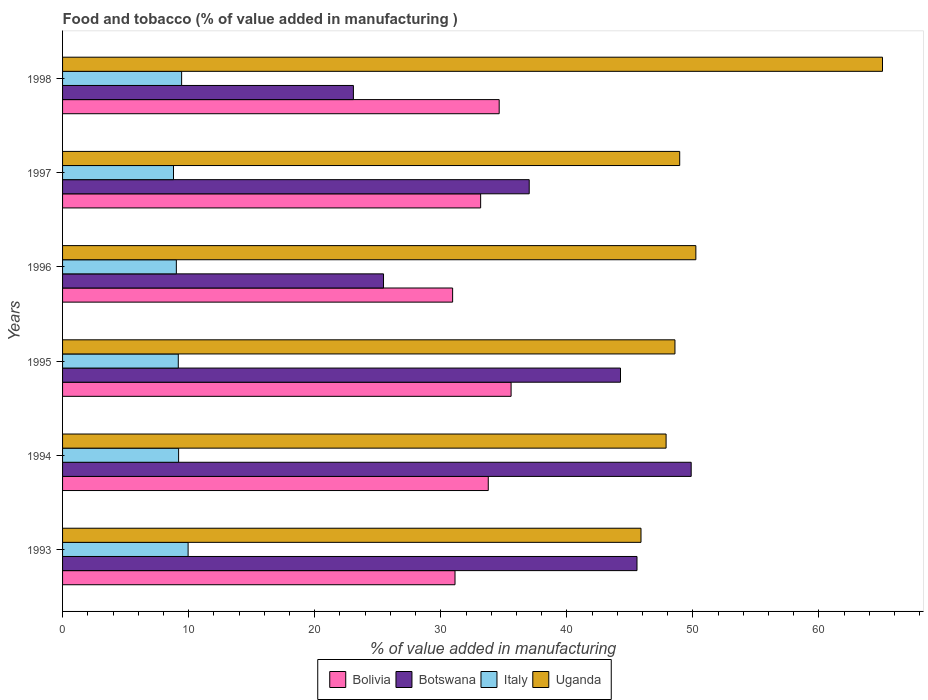How many groups of bars are there?
Your response must be concise. 6. How many bars are there on the 4th tick from the bottom?
Make the answer very short. 4. In how many cases, is the number of bars for a given year not equal to the number of legend labels?
Make the answer very short. 0. What is the value added in manufacturing food and tobacco in Botswana in 1993?
Give a very brief answer. 45.56. Across all years, what is the maximum value added in manufacturing food and tobacco in Italy?
Offer a terse response. 9.96. Across all years, what is the minimum value added in manufacturing food and tobacco in Botswana?
Provide a succinct answer. 23.07. What is the total value added in manufacturing food and tobacco in Bolivia in the graph?
Your response must be concise. 199.21. What is the difference between the value added in manufacturing food and tobacco in Italy in 1996 and that in 1998?
Your answer should be very brief. -0.42. What is the difference between the value added in manufacturing food and tobacco in Bolivia in 1994 and the value added in manufacturing food and tobacco in Botswana in 1998?
Make the answer very short. 10.7. What is the average value added in manufacturing food and tobacco in Bolivia per year?
Your answer should be compact. 33.2. In the year 1993, what is the difference between the value added in manufacturing food and tobacco in Italy and value added in manufacturing food and tobacco in Uganda?
Keep it short and to the point. -35.92. What is the ratio of the value added in manufacturing food and tobacco in Uganda in 1993 to that in 1996?
Your response must be concise. 0.91. What is the difference between the highest and the second highest value added in manufacturing food and tobacco in Botswana?
Keep it short and to the point. 4.3. What is the difference between the highest and the lowest value added in manufacturing food and tobacco in Italy?
Your answer should be compact. 1.16. Is the sum of the value added in manufacturing food and tobacco in Bolivia in 1996 and 1997 greater than the maximum value added in manufacturing food and tobacco in Botswana across all years?
Provide a succinct answer. Yes. What does the 1st bar from the top in 1998 represents?
Provide a succinct answer. Uganda. What does the 2nd bar from the bottom in 1993 represents?
Make the answer very short. Botswana. Are all the bars in the graph horizontal?
Give a very brief answer. Yes. How are the legend labels stacked?
Your answer should be compact. Horizontal. What is the title of the graph?
Provide a short and direct response. Food and tobacco (% of value added in manufacturing ). What is the label or title of the X-axis?
Make the answer very short. % of value added in manufacturing. What is the % of value added in manufacturing in Bolivia in 1993?
Provide a short and direct response. 31.13. What is the % of value added in manufacturing in Botswana in 1993?
Provide a succinct answer. 45.56. What is the % of value added in manufacturing of Italy in 1993?
Offer a terse response. 9.96. What is the % of value added in manufacturing of Uganda in 1993?
Make the answer very short. 45.88. What is the % of value added in manufacturing of Bolivia in 1994?
Keep it short and to the point. 33.77. What is the % of value added in manufacturing in Botswana in 1994?
Provide a succinct answer. 49.86. What is the % of value added in manufacturing in Italy in 1994?
Make the answer very short. 9.21. What is the % of value added in manufacturing of Uganda in 1994?
Ensure brevity in your answer.  47.87. What is the % of value added in manufacturing of Bolivia in 1995?
Your answer should be very brief. 35.58. What is the % of value added in manufacturing of Botswana in 1995?
Provide a succinct answer. 44.26. What is the % of value added in manufacturing of Italy in 1995?
Give a very brief answer. 9.18. What is the % of value added in manufacturing in Uganda in 1995?
Make the answer very short. 48.57. What is the % of value added in manufacturing in Bolivia in 1996?
Your answer should be very brief. 30.94. What is the % of value added in manufacturing of Botswana in 1996?
Give a very brief answer. 25.46. What is the % of value added in manufacturing in Italy in 1996?
Ensure brevity in your answer.  9.03. What is the % of value added in manufacturing in Uganda in 1996?
Provide a succinct answer. 50.23. What is the % of value added in manufacturing in Bolivia in 1997?
Provide a succinct answer. 33.16. What is the % of value added in manufacturing in Botswana in 1997?
Offer a terse response. 37.02. What is the % of value added in manufacturing of Italy in 1997?
Make the answer very short. 8.8. What is the % of value added in manufacturing of Uganda in 1997?
Ensure brevity in your answer.  48.95. What is the % of value added in manufacturing of Bolivia in 1998?
Make the answer very short. 34.63. What is the % of value added in manufacturing of Botswana in 1998?
Ensure brevity in your answer.  23.07. What is the % of value added in manufacturing of Italy in 1998?
Provide a succinct answer. 9.44. What is the % of value added in manufacturing in Uganda in 1998?
Ensure brevity in your answer.  65.04. Across all years, what is the maximum % of value added in manufacturing in Bolivia?
Offer a very short reply. 35.58. Across all years, what is the maximum % of value added in manufacturing in Botswana?
Your answer should be very brief. 49.86. Across all years, what is the maximum % of value added in manufacturing in Italy?
Ensure brevity in your answer.  9.96. Across all years, what is the maximum % of value added in manufacturing in Uganda?
Your response must be concise. 65.04. Across all years, what is the minimum % of value added in manufacturing in Bolivia?
Keep it short and to the point. 30.94. Across all years, what is the minimum % of value added in manufacturing in Botswana?
Make the answer very short. 23.07. Across all years, what is the minimum % of value added in manufacturing of Italy?
Your answer should be very brief. 8.8. Across all years, what is the minimum % of value added in manufacturing in Uganda?
Your answer should be very brief. 45.88. What is the total % of value added in manufacturing of Bolivia in the graph?
Make the answer very short. 199.21. What is the total % of value added in manufacturing in Botswana in the graph?
Your answer should be compact. 225.22. What is the total % of value added in manufacturing of Italy in the graph?
Offer a very short reply. 55.61. What is the total % of value added in manufacturing of Uganda in the graph?
Your answer should be very brief. 306.55. What is the difference between the % of value added in manufacturing in Bolivia in 1993 and that in 1994?
Provide a short and direct response. -2.64. What is the difference between the % of value added in manufacturing of Botswana in 1993 and that in 1994?
Ensure brevity in your answer.  -4.3. What is the difference between the % of value added in manufacturing in Italy in 1993 and that in 1994?
Give a very brief answer. 0.75. What is the difference between the % of value added in manufacturing of Uganda in 1993 and that in 1994?
Your answer should be very brief. -1.99. What is the difference between the % of value added in manufacturing in Bolivia in 1993 and that in 1995?
Your answer should be very brief. -4.45. What is the difference between the % of value added in manufacturing in Botswana in 1993 and that in 1995?
Offer a terse response. 1.31. What is the difference between the % of value added in manufacturing in Italy in 1993 and that in 1995?
Ensure brevity in your answer.  0.78. What is the difference between the % of value added in manufacturing in Uganda in 1993 and that in 1995?
Give a very brief answer. -2.69. What is the difference between the % of value added in manufacturing in Bolivia in 1993 and that in 1996?
Your answer should be very brief. 0.19. What is the difference between the % of value added in manufacturing in Botswana in 1993 and that in 1996?
Make the answer very short. 20.11. What is the difference between the % of value added in manufacturing of Uganda in 1993 and that in 1996?
Provide a succinct answer. -4.35. What is the difference between the % of value added in manufacturing of Bolivia in 1993 and that in 1997?
Offer a terse response. -2.03. What is the difference between the % of value added in manufacturing in Botswana in 1993 and that in 1997?
Ensure brevity in your answer.  8.55. What is the difference between the % of value added in manufacturing of Italy in 1993 and that in 1997?
Make the answer very short. 1.16. What is the difference between the % of value added in manufacturing in Uganda in 1993 and that in 1997?
Make the answer very short. -3.07. What is the difference between the % of value added in manufacturing in Bolivia in 1993 and that in 1998?
Make the answer very short. -3.5. What is the difference between the % of value added in manufacturing in Botswana in 1993 and that in 1998?
Provide a short and direct response. 22.49. What is the difference between the % of value added in manufacturing of Italy in 1993 and that in 1998?
Ensure brevity in your answer.  0.51. What is the difference between the % of value added in manufacturing in Uganda in 1993 and that in 1998?
Provide a succinct answer. -19.16. What is the difference between the % of value added in manufacturing of Bolivia in 1994 and that in 1995?
Offer a very short reply. -1.81. What is the difference between the % of value added in manufacturing in Botswana in 1994 and that in 1995?
Provide a succinct answer. 5.61. What is the difference between the % of value added in manufacturing in Italy in 1994 and that in 1995?
Offer a terse response. 0.03. What is the difference between the % of value added in manufacturing in Uganda in 1994 and that in 1995?
Make the answer very short. -0.7. What is the difference between the % of value added in manufacturing of Bolivia in 1994 and that in 1996?
Keep it short and to the point. 2.83. What is the difference between the % of value added in manufacturing of Botswana in 1994 and that in 1996?
Give a very brief answer. 24.4. What is the difference between the % of value added in manufacturing in Italy in 1994 and that in 1996?
Keep it short and to the point. 0.18. What is the difference between the % of value added in manufacturing in Uganda in 1994 and that in 1996?
Make the answer very short. -2.36. What is the difference between the % of value added in manufacturing in Bolivia in 1994 and that in 1997?
Offer a very short reply. 0.6. What is the difference between the % of value added in manufacturing in Botswana in 1994 and that in 1997?
Give a very brief answer. 12.85. What is the difference between the % of value added in manufacturing of Italy in 1994 and that in 1997?
Provide a short and direct response. 0.41. What is the difference between the % of value added in manufacturing in Uganda in 1994 and that in 1997?
Provide a succinct answer. -1.08. What is the difference between the % of value added in manufacturing in Bolivia in 1994 and that in 1998?
Provide a short and direct response. -0.87. What is the difference between the % of value added in manufacturing in Botswana in 1994 and that in 1998?
Keep it short and to the point. 26.79. What is the difference between the % of value added in manufacturing in Italy in 1994 and that in 1998?
Provide a short and direct response. -0.24. What is the difference between the % of value added in manufacturing of Uganda in 1994 and that in 1998?
Make the answer very short. -17.16. What is the difference between the % of value added in manufacturing of Bolivia in 1995 and that in 1996?
Your response must be concise. 4.64. What is the difference between the % of value added in manufacturing of Botswana in 1995 and that in 1996?
Give a very brief answer. 18.8. What is the difference between the % of value added in manufacturing of Italy in 1995 and that in 1996?
Ensure brevity in your answer.  0.15. What is the difference between the % of value added in manufacturing of Uganda in 1995 and that in 1996?
Make the answer very short. -1.66. What is the difference between the % of value added in manufacturing of Bolivia in 1995 and that in 1997?
Your answer should be very brief. 2.41. What is the difference between the % of value added in manufacturing of Botswana in 1995 and that in 1997?
Provide a succinct answer. 7.24. What is the difference between the % of value added in manufacturing in Italy in 1995 and that in 1997?
Your answer should be very brief. 0.38. What is the difference between the % of value added in manufacturing of Uganda in 1995 and that in 1997?
Offer a terse response. -0.38. What is the difference between the % of value added in manufacturing of Bolivia in 1995 and that in 1998?
Offer a very short reply. 0.94. What is the difference between the % of value added in manufacturing in Botswana in 1995 and that in 1998?
Provide a succinct answer. 21.19. What is the difference between the % of value added in manufacturing in Italy in 1995 and that in 1998?
Keep it short and to the point. -0.27. What is the difference between the % of value added in manufacturing in Uganda in 1995 and that in 1998?
Offer a very short reply. -16.46. What is the difference between the % of value added in manufacturing of Bolivia in 1996 and that in 1997?
Keep it short and to the point. -2.22. What is the difference between the % of value added in manufacturing in Botswana in 1996 and that in 1997?
Give a very brief answer. -11.56. What is the difference between the % of value added in manufacturing in Italy in 1996 and that in 1997?
Give a very brief answer. 0.23. What is the difference between the % of value added in manufacturing in Uganda in 1996 and that in 1997?
Provide a succinct answer. 1.28. What is the difference between the % of value added in manufacturing in Bolivia in 1996 and that in 1998?
Your answer should be very brief. -3.69. What is the difference between the % of value added in manufacturing in Botswana in 1996 and that in 1998?
Your answer should be compact. 2.39. What is the difference between the % of value added in manufacturing of Italy in 1996 and that in 1998?
Keep it short and to the point. -0.42. What is the difference between the % of value added in manufacturing of Uganda in 1996 and that in 1998?
Your answer should be compact. -14.8. What is the difference between the % of value added in manufacturing in Bolivia in 1997 and that in 1998?
Ensure brevity in your answer.  -1.47. What is the difference between the % of value added in manufacturing in Botswana in 1997 and that in 1998?
Provide a short and direct response. 13.95. What is the difference between the % of value added in manufacturing in Italy in 1997 and that in 1998?
Make the answer very short. -0.64. What is the difference between the % of value added in manufacturing in Uganda in 1997 and that in 1998?
Ensure brevity in your answer.  -16.09. What is the difference between the % of value added in manufacturing of Bolivia in 1993 and the % of value added in manufacturing of Botswana in 1994?
Provide a succinct answer. -18.73. What is the difference between the % of value added in manufacturing of Bolivia in 1993 and the % of value added in manufacturing of Italy in 1994?
Keep it short and to the point. 21.92. What is the difference between the % of value added in manufacturing in Bolivia in 1993 and the % of value added in manufacturing in Uganda in 1994?
Your answer should be compact. -16.74. What is the difference between the % of value added in manufacturing in Botswana in 1993 and the % of value added in manufacturing in Italy in 1994?
Keep it short and to the point. 36.36. What is the difference between the % of value added in manufacturing in Botswana in 1993 and the % of value added in manufacturing in Uganda in 1994?
Keep it short and to the point. -2.31. What is the difference between the % of value added in manufacturing of Italy in 1993 and the % of value added in manufacturing of Uganda in 1994?
Your answer should be very brief. -37.91. What is the difference between the % of value added in manufacturing in Bolivia in 1993 and the % of value added in manufacturing in Botswana in 1995?
Ensure brevity in your answer.  -13.13. What is the difference between the % of value added in manufacturing of Bolivia in 1993 and the % of value added in manufacturing of Italy in 1995?
Keep it short and to the point. 21.95. What is the difference between the % of value added in manufacturing in Bolivia in 1993 and the % of value added in manufacturing in Uganda in 1995?
Make the answer very short. -17.45. What is the difference between the % of value added in manufacturing of Botswana in 1993 and the % of value added in manufacturing of Italy in 1995?
Your response must be concise. 36.39. What is the difference between the % of value added in manufacturing of Botswana in 1993 and the % of value added in manufacturing of Uganda in 1995?
Give a very brief answer. -3.01. What is the difference between the % of value added in manufacturing of Italy in 1993 and the % of value added in manufacturing of Uganda in 1995?
Ensure brevity in your answer.  -38.62. What is the difference between the % of value added in manufacturing of Bolivia in 1993 and the % of value added in manufacturing of Botswana in 1996?
Your answer should be very brief. 5.67. What is the difference between the % of value added in manufacturing in Bolivia in 1993 and the % of value added in manufacturing in Italy in 1996?
Give a very brief answer. 22.1. What is the difference between the % of value added in manufacturing of Bolivia in 1993 and the % of value added in manufacturing of Uganda in 1996?
Your answer should be compact. -19.1. What is the difference between the % of value added in manufacturing in Botswana in 1993 and the % of value added in manufacturing in Italy in 1996?
Offer a very short reply. 36.54. What is the difference between the % of value added in manufacturing of Botswana in 1993 and the % of value added in manufacturing of Uganda in 1996?
Offer a very short reply. -4.67. What is the difference between the % of value added in manufacturing of Italy in 1993 and the % of value added in manufacturing of Uganda in 1996?
Provide a short and direct response. -40.27. What is the difference between the % of value added in manufacturing of Bolivia in 1993 and the % of value added in manufacturing of Botswana in 1997?
Provide a succinct answer. -5.89. What is the difference between the % of value added in manufacturing in Bolivia in 1993 and the % of value added in manufacturing in Italy in 1997?
Offer a terse response. 22.33. What is the difference between the % of value added in manufacturing of Bolivia in 1993 and the % of value added in manufacturing of Uganda in 1997?
Your answer should be compact. -17.82. What is the difference between the % of value added in manufacturing in Botswana in 1993 and the % of value added in manufacturing in Italy in 1997?
Provide a short and direct response. 36.76. What is the difference between the % of value added in manufacturing in Botswana in 1993 and the % of value added in manufacturing in Uganda in 1997?
Your answer should be compact. -3.39. What is the difference between the % of value added in manufacturing of Italy in 1993 and the % of value added in manufacturing of Uganda in 1997?
Ensure brevity in your answer.  -38.99. What is the difference between the % of value added in manufacturing in Bolivia in 1993 and the % of value added in manufacturing in Botswana in 1998?
Provide a succinct answer. 8.06. What is the difference between the % of value added in manufacturing in Bolivia in 1993 and the % of value added in manufacturing in Italy in 1998?
Give a very brief answer. 21.68. What is the difference between the % of value added in manufacturing in Bolivia in 1993 and the % of value added in manufacturing in Uganda in 1998?
Your answer should be compact. -33.91. What is the difference between the % of value added in manufacturing in Botswana in 1993 and the % of value added in manufacturing in Italy in 1998?
Offer a terse response. 36.12. What is the difference between the % of value added in manufacturing in Botswana in 1993 and the % of value added in manufacturing in Uganda in 1998?
Make the answer very short. -19.47. What is the difference between the % of value added in manufacturing in Italy in 1993 and the % of value added in manufacturing in Uganda in 1998?
Your answer should be very brief. -55.08. What is the difference between the % of value added in manufacturing of Bolivia in 1994 and the % of value added in manufacturing of Botswana in 1995?
Offer a terse response. -10.49. What is the difference between the % of value added in manufacturing in Bolivia in 1994 and the % of value added in manufacturing in Italy in 1995?
Your answer should be very brief. 24.59. What is the difference between the % of value added in manufacturing in Bolivia in 1994 and the % of value added in manufacturing in Uganda in 1995?
Ensure brevity in your answer.  -14.81. What is the difference between the % of value added in manufacturing of Botswana in 1994 and the % of value added in manufacturing of Italy in 1995?
Provide a short and direct response. 40.68. What is the difference between the % of value added in manufacturing of Botswana in 1994 and the % of value added in manufacturing of Uganda in 1995?
Your response must be concise. 1.29. What is the difference between the % of value added in manufacturing in Italy in 1994 and the % of value added in manufacturing in Uganda in 1995?
Make the answer very short. -39.37. What is the difference between the % of value added in manufacturing of Bolivia in 1994 and the % of value added in manufacturing of Botswana in 1996?
Ensure brevity in your answer.  8.31. What is the difference between the % of value added in manufacturing in Bolivia in 1994 and the % of value added in manufacturing in Italy in 1996?
Offer a very short reply. 24.74. What is the difference between the % of value added in manufacturing of Bolivia in 1994 and the % of value added in manufacturing of Uganda in 1996?
Provide a short and direct response. -16.47. What is the difference between the % of value added in manufacturing in Botswana in 1994 and the % of value added in manufacturing in Italy in 1996?
Make the answer very short. 40.84. What is the difference between the % of value added in manufacturing in Botswana in 1994 and the % of value added in manufacturing in Uganda in 1996?
Make the answer very short. -0.37. What is the difference between the % of value added in manufacturing of Italy in 1994 and the % of value added in manufacturing of Uganda in 1996?
Your answer should be very brief. -41.03. What is the difference between the % of value added in manufacturing in Bolivia in 1994 and the % of value added in manufacturing in Botswana in 1997?
Make the answer very short. -3.25. What is the difference between the % of value added in manufacturing of Bolivia in 1994 and the % of value added in manufacturing of Italy in 1997?
Give a very brief answer. 24.97. What is the difference between the % of value added in manufacturing in Bolivia in 1994 and the % of value added in manufacturing in Uganda in 1997?
Provide a succinct answer. -15.19. What is the difference between the % of value added in manufacturing in Botswana in 1994 and the % of value added in manufacturing in Italy in 1997?
Make the answer very short. 41.06. What is the difference between the % of value added in manufacturing in Botswana in 1994 and the % of value added in manufacturing in Uganda in 1997?
Your answer should be very brief. 0.91. What is the difference between the % of value added in manufacturing of Italy in 1994 and the % of value added in manufacturing of Uganda in 1997?
Your answer should be compact. -39.75. What is the difference between the % of value added in manufacturing in Bolivia in 1994 and the % of value added in manufacturing in Botswana in 1998?
Your response must be concise. 10.7. What is the difference between the % of value added in manufacturing in Bolivia in 1994 and the % of value added in manufacturing in Italy in 1998?
Offer a very short reply. 24.32. What is the difference between the % of value added in manufacturing of Bolivia in 1994 and the % of value added in manufacturing of Uganda in 1998?
Your response must be concise. -31.27. What is the difference between the % of value added in manufacturing of Botswana in 1994 and the % of value added in manufacturing of Italy in 1998?
Your answer should be very brief. 40.42. What is the difference between the % of value added in manufacturing of Botswana in 1994 and the % of value added in manufacturing of Uganda in 1998?
Keep it short and to the point. -15.18. What is the difference between the % of value added in manufacturing of Italy in 1994 and the % of value added in manufacturing of Uganda in 1998?
Make the answer very short. -55.83. What is the difference between the % of value added in manufacturing of Bolivia in 1995 and the % of value added in manufacturing of Botswana in 1996?
Keep it short and to the point. 10.12. What is the difference between the % of value added in manufacturing in Bolivia in 1995 and the % of value added in manufacturing in Italy in 1996?
Give a very brief answer. 26.55. What is the difference between the % of value added in manufacturing in Bolivia in 1995 and the % of value added in manufacturing in Uganda in 1996?
Make the answer very short. -14.66. What is the difference between the % of value added in manufacturing of Botswana in 1995 and the % of value added in manufacturing of Italy in 1996?
Your answer should be compact. 35.23. What is the difference between the % of value added in manufacturing in Botswana in 1995 and the % of value added in manufacturing in Uganda in 1996?
Make the answer very short. -5.98. What is the difference between the % of value added in manufacturing of Italy in 1995 and the % of value added in manufacturing of Uganda in 1996?
Your response must be concise. -41.05. What is the difference between the % of value added in manufacturing of Bolivia in 1995 and the % of value added in manufacturing of Botswana in 1997?
Provide a succinct answer. -1.44. What is the difference between the % of value added in manufacturing of Bolivia in 1995 and the % of value added in manufacturing of Italy in 1997?
Provide a succinct answer. 26.78. What is the difference between the % of value added in manufacturing in Bolivia in 1995 and the % of value added in manufacturing in Uganda in 1997?
Keep it short and to the point. -13.38. What is the difference between the % of value added in manufacturing of Botswana in 1995 and the % of value added in manufacturing of Italy in 1997?
Provide a succinct answer. 35.46. What is the difference between the % of value added in manufacturing in Botswana in 1995 and the % of value added in manufacturing in Uganda in 1997?
Provide a short and direct response. -4.7. What is the difference between the % of value added in manufacturing of Italy in 1995 and the % of value added in manufacturing of Uganda in 1997?
Offer a very short reply. -39.77. What is the difference between the % of value added in manufacturing in Bolivia in 1995 and the % of value added in manufacturing in Botswana in 1998?
Provide a short and direct response. 12.51. What is the difference between the % of value added in manufacturing in Bolivia in 1995 and the % of value added in manufacturing in Italy in 1998?
Offer a terse response. 26.13. What is the difference between the % of value added in manufacturing in Bolivia in 1995 and the % of value added in manufacturing in Uganda in 1998?
Ensure brevity in your answer.  -29.46. What is the difference between the % of value added in manufacturing in Botswana in 1995 and the % of value added in manufacturing in Italy in 1998?
Make the answer very short. 34.81. What is the difference between the % of value added in manufacturing of Botswana in 1995 and the % of value added in manufacturing of Uganda in 1998?
Your answer should be very brief. -20.78. What is the difference between the % of value added in manufacturing of Italy in 1995 and the % of value added in manufacturing of Uganda in 1998?
Your response must be concise. -55.86. What is the difference between the % of value added in manufacturing of Bolivia in 1996 and the % of value added in manufacturing of Botswana in 1997?
Ensure brevity in your answer.  -6.08. What is the difference between the % of value added in manufacturing of Bolivia in 1996 and the % of value added in manufacturing of Italy in 1997?
Give a very brief answer. 22.14. What is the difference between the % of value added in manufacturing of Bolivia in 1996 and the % of value added in manufacturing of Uganda in 1997?
Provide a short and direct response. -18.01. What is the difference between the % of value added in manufacturing in Botswana in 1996 and the % of value added in manufacturing in Italy in 1997?
Keep it short and to the point. 16.66. What is the difference between the % of value added in manufacturing of Botswana in 1996 and the % of value added in manufacturing of Uganda in 1997?
Your answer should be very brief. -23.49. What is the difference between the % of value added in manufacturing in Italy in 1996 and the % of value added in manufacturing in Uganda in 1997?
Offer a very short reply. -39.93. What is the difference between the % of value added in manufacturing of Bolivia in 1996 and the % of value added in manufacturing of Botswana in 1998?
Offer a very short reply. 7.87. What is the difference between the % of value added in manufacturing of Bolivia in 1996 and the % of value added in manufacturing of Italy in 1998?
Provide a succinct answer. 21.5. What is the difference between the % of value added in manufacturing of Bolivia in 1996 and the % of value added in manufacturing of Uganda in 1998?
Give a very brief answer. -34.1. What is the difference between the % of value added in manufacturing of Botswana in 1996 and the % of value added in manufacturing of Italy in 1998?
Your answer should be very brief. 16.01. What is the difference between the % of value added in manufacturing in Botswana in 1996 and the % of value added in manufacturing in Uganda in 1998?
Your answer should be compact. -39.58. What is the difference between the % of value added in manufacturing of Italy in 1996 and the % of value added in manufacturing of Uganda in 1998?
Make the answer very short. -56.01. What is the difference between the % of value added in manufacturing in Bolivia in 1997 and the % of value added in manufacturing in Botswana in 1998?
Provide a short and direct response. 10.09. What is the difference between the % of value added in manufacturing in Bolivia in 1997 and the % of value added in manufacturing in Italy in 1998?
Provide a short and direct response. 23.72. What is the difference between the % of value added in manufacturing in Bolivia in 1997 and the % of value added in manufacturing in Uganda in 1998?
Give a very brief answer. -31.87. What is the difference between the % of value added in manufacturing of Botswana in 1997 and the % of value added in manufacturing of Italy in 1998?
Provide a succinct answer. 27.57. What is the difference between the % of value added in manufacturing of Botswana in 1997 and the % of value added in manufacturing of Uganda in 1998?
Give a very brief answer. -28.02. What is the difference between the % of value added in manufacturing in Italy in 1997 and the % of value added in manufacturing in Uganda in 1998?
Provide a short and direct response. -56.24. What is the average % of value added in manufacturing in Bolivia per year?
Keep it short and to the point. 33.2. What is the average % of value added in manufacturing of Botswana per year?
Offer a terse response. 37.54. What is the average % of value added in manufacturing in Italy per year?
Keep it short and to the point. 9.27. What is the average % of value added in manufacturing in Uganda per year?
Ensure brevity in your answer.  51.09. In the year 1993, what is the difference between the % of value added in manufacturing of Bolivia and % of value added in manufacturing of Botswana?
Give a very brief answer. -14.44. In the year 1993, what is the difference between the % of value added in manufacturing of Bolivia and % of value added in manufacturing of Italy?
Your answer should be very brief. 21.17. In the year 1993, what is the difference between the % of value added in manufacturing in Bolivia and % of value added in manufacturing in Uganda?
Make the answer very short. -14.75. In the year 1993, what is the difference between the % of value added in manufacturing in Botswana and % of value added in manufacturing in Italy?
Give a very brief answer. 35.61. In the year 1993, what is the difference between the % of value added in manufacturing of Botswana and % of value added in manufacturing of Uganda?
Ensure brevity in your answer.  -0.32. In the year 1993, what is the difference between the % of value added in manufacturing in Italy and % of value added in manufacturing in Uganda?
Your answer should be compact. -35.92. In the year 1994, what is the difference between the % of value added in manufacturing in Bolivia and % of value added in manufacturing in Botswana?
Offer a terse response. -16.1. In the year 1994, what is the difference between the % of value added in manufacturing of Bolivia and % of value added in manufacturing of Italy?
Keep it short and to the point. 24.56. In the year 1994, what is the difference between the % of value added in manufacturing of Bolivia and % of value added in manufacturing of Uganda?
Offer a terse response. -14.11. In the year 1994, what is the difference between the % of value added in manufacturing in Botswana and % of value added in manufacturing in Italy?
Your answer should be compact. 40.66. In the year 1994, what is the difference between the % of value added in manufacturing in Botswana and % of value added in manufacturing in Uganda?
Give a very brief answer. 1.99. In the year 1994, what is the difference between the % of value added in manufacturing of Italy and % of value added in manufacturing of Uganda?
Offer a very short reply. -38.67. In the year 1995, what is the difference between the % of value added in manufacturing in Bolivia and % of value added in manufacturing in Botswana?
Make the answer very short. -8.68. In the year 1995, what is the difference between the % of value added in manufacturing in Bolivia and % of value added in manufacturing in Italy?
Provide a short and direct response. 26.4. In the year 1995, what is the difference between the % of value added in manufacturing of Bolivia and % of value added in manufacturing of Uganda?
Make the answer very short. -13. In the year 1995, what is the difference between the % of value added in manufacturing of Botswana and % of value added in manufacturing of Italy?
Ensure brevity in your answer.  35.08. In the year 1995, what is the difference between the % of value added in manufacturing of Botswana and % of value added in manufacturing of Uganda?
Offer a very short reply. -4.32. In the year 1995, what is the difference between the % of value added in manufacturing of Italy and % of value added in manufacturing of Uganda?
Your answer should be compact. -39.4. In the year 1996, what is the difference between the % of value added in manufacturing of Bolivia and % of value added in manufacturing of Botswana?
Keep it short and to the point. 5.48. In the year 1996, what is the difference between the % of value added in manufacturing of Bolivia and % of value added in manufacturing of Italy?
Your answer should be compact. 21.91. In the year 1996, what is the difference between the % of value added in manufacturing in Bolivia and % of value added in manufacturing in Uganda?
Provide a succinct answer. -19.29. In the year 1996, what is the difference between the % of value added in manufacturing in Botswana and % of value added in manufacturing in Italy?
Offer a terse response. 16.43. In the year 1996, what is the difference between the % of value added in manufacturing of Botswana and % of value added in manufacturing of Uganda?
Offer a very short reply. -24.78. In the year 1996, what is the difference between the % of value added in manufacturing of Italy and % of value added in manufacturing of Uganda?
Your response must be concise. -41.21. In the year 1997, what is the difference between the % of value added in manufacturing of Bolivia and % of value added in manufacturing of Botswana?
Your response must be concise. -3.85. In the year 1997, what is the difference between the % of value added in manufacturing of Bolivia and % of value added in manufacturing of Italy?
Keep it short and to the point. 24.36. In the year 1997, what is the difference between the % of value added in manufacturing in Bolivia and % of value added in manufacturing in Uganda?
Ensure brevity in your answer.  -15.79. In the year 1997, what is the difference between the % of value added in manufacturing in Botswana and % of value added in manufacturing in Italy?
Provide a short and direct response. 28.22. In the year 1997, what is the difference between the % of value added in manufacturing in Botswana and % of value added in manufacturing in Uganda?
Offer a terse response. -11.94. In the year 1997, what is the difference between the % of value added in manufacturing in Italy and % of value added in manufacturing in Uganda?
Your response must be concise. -40.15. In the year 1998, what is the difference between the % of value added in manufacturing of Bolivia and % of value added in manufacturing of Botswana?
Give a very brief answer. 11.56. In the year 1998, what is the difference between the % of value added in manufacturing of Bolivia and % of value added in manufacturing of Italy?
Ensure brevity in your answer.  25.19. In the year 1998, what is the difference between the % of value added in manufacturing in Bolivia and % of value added in manufacturing in Uganda?
Keep it short and to the point. -30.4. In the year 1998, what is the difference between the % of value added in manufacturing of Botswana and % of value added in manufacturing of Italy?
Provide a short and direct response. 13.63. In the year 1998, what is the difference between the % of value added in manufacturing of Botswana and % of value added in manufacturing of Uganda?
Your answer should be very brief. -41.97. In the year 1998, what is the difference between the % of value added in manufacturing in Italy and % of value added in manufacturing in Uganda?
Make the answer very short. -55.59. What is the ratio of the % of value added in manufacturing of Bolivia in 1993 to that in 1994?
Provide a succinct answer. 0.92. What is the ratio of the % of value added in manufacturing in Botswana in 1993 to that in 1994?
Your answer should be very brief. 0.91. What is the ratio of the % of value added in manufacturing of Italy in 1993 to that in 1994?
Your response must be concise. 1.08. What is the ratio of the % of value added in manufacturing of Uganda in 1993 to that in 1994?
Keep it short and to the point. 0.96. What is the ratio of the % of value added in manufacturing of Bolivia in 1993 to that in 1995?
Provide a succinct answer. 0.88. What is the ratio of the % of value added in manufacturing in Botswana in 1993 to that in 1995?
Your answer should be compact. 1.03. What is the ratio of the % of value added in manufacturing in Italy in 1993 to that in 1995?
Your response must be concise. 1.08. What is the ratio of the % of value added in manufacturing in Uganda in 1993 to that in 1995?
Offer a terse response. 0.94. What is the ratio of the % of value added in manufacturing in Bolivia in 1993 to that in 1996?
Offer a very short reply. 1.01. What is the ratio of the % of value added in manufacturing in Botswana in 1993 to that in 1996?
Keep it short and to the point. 1.79. What is the ratio of the % of value added in manufacturing in Italy in 1993 to that in 1996?
Give a very brief answer. 1.1. What is the ratio of the % of value added in manufacturing in Uganda in 1993 to that in 1996?
Provide a succinct answer. 0.91. What is the ratio of the % of value added in manufacturing in Bolivia in 1993 to that in 1997?
Your response must be concise. 0.94. What is the ratio of the % of value added in manufacturing of Botswana in 1993 to that in 1997?
Offer a terse response. 1.23. What is the ratio of the % of value added in manufacturing of Italy in 1993 to that in 1997?
Your answer should be compact. 1.13. What is the ratio of the % of value added in manufacturing in Uganda in 1993 to that in 1997?
Offer a terse response. 0.94. What is the ratio of the % of value added in manufacturing in Bolivia in 1993 to that in 1998?
Your answer should be compact. 0.9. What is the ratio of the % of value added in manufacturing in Botswana in 1993 to that in 1998?
Keep it short and to the point. 1.98. What is the ratio of the % of value added in manufacturing in Italy in 1993 to that in 1998?
Offer a very short reply. 1.05. What is the ratio of the % of value added in manufacturing of Uganda in 1993 to that in 1998?
Ensure brevity in your answer.  0.71. What is the ratio of the % of value added in manufacturing of Bolivia in 1994 to that in 1995?
Provide a succinct answer. 0.95. What is the ratio of the % of value added in manufacturing of Botswana in 1994 to that in 1995?
Keep it short and to the point. 1.13. What is the ratio of the % of value added in manufacturing of Uganda in 1994 to that in 1995?
Offer a terse response. 0.99. What is the ratio of the % of value added in manufacturing in Bolivia in 1994 to that in 1996?
Your answer should be compact. 1.09. What is the ratio of the % of value added in manufacturing of Botswana in 1994 to that in 1996?
Make the answer very short. 1.96. What is the ratio of the % of value added in manufacturing of Italy in 1994 to that in 1996?
Your answer should be very brief. 1.02. What is the ratio of the % of value added in manufacturing in Uganda in 1994 to that in 1996?
Your answer should be compact. 0.95. What is the ratio of the % of value added in manufacturing in Bolivia in 1994 to that in 1997?
Your response must be concise. 1.02. What is the ratio of the % of value added in manufacturing of Botswana in 1994 to that in 1997?
Give a very brief answer. 1.35. What is the ratio of the % of value added in manufacturing of Italy in 1994 to that in 1997?
Your response must be concise. 1.05. What is the ratio of the % of value added in manufacturing of Uganda in 1994 to that in 1997?
Give a very brief answer. 0.98. What is the ratio of the % of value added in manufacturing in Bolivia in 1994 to that in 1998?
Ensure brevity in your answer.  0.97. What is the ratio of the % of value added in manufacturing in Botswana in 1994 to that in 1998?
Your answer should be compact. 2.16. What is the ratio of the % of value added in manufacturing in Italy in 1994 to that in 1998?
Your answer should be very brief. 0.97. What is the ratio of the % of value added in manufacturing of Uganda in 1994 to that in 1998?
Provide a short and direct response. 0.74. What is the ratio of the % of value added in manufacturing of Bolivia in 1995 to that in 1996?
Keep it short and to the point. 1.15. What is the ratio of the % of value added in manufacturing of Botswana in 1995 to that in 1996?
Offer a very short reply. 1.74. What is the ratio of the % of value added in manufacturing of Italy in 1995 to that in 1996?
Keep it short and to the point. 1.02. What is the ratio of the % of value added in manufacturing of Uganda in 1995 to that in 1996?
Provide a short and direct response. 0.97. What is the ratio of the % of value added in manufacturing of Bolivia in 1995 to that in 1997?
Your answer should be very brief. 1.07. What is the ratio of the % of value added in manufacturing in Botswana in 1995 to that in 1997?
Your response must be concise. 1.2. What is the ratio of the % of value added in manufacturing of Italy in 1995 to that in 1997?
Your response must be concise. 1.04. What is the ratio of the % of value added in manufacturing of Bolivia in 1995 to that in 1998?
Keep it short and to the point. 1.03. What is the ratio of the % of value added in manufacturing of Botswana in 1995 to that in 1998?
Give a very brief answer. 1.92. What is the ratio of the % of value added in manufacturing of Italy in 1995 to that in 1998?
Your answer should be compact. 0.97. What is the ratio of the % of value added in manufacturing of Uganda in 1995 to that in 1998?
Your response must be concise. 0.75. What is the ratio of the % of value added in manufacturing in Bolivia in 1996 to that in 1997?
Provide a succinct answer. 0.93. What is the ratio of the % of value added in manufacturing in Botswana in 1996 to that in 1997?
Provide a succinct answer. 0.69. What is the ratio of the % of value added in manufacturing in Italy in 1996 to that in 1997?
Your response must be concise. 1.03. What is the ratio of the % of value added in manufacturing of Uganda in 1996 to that in 1997?
Keep it short and to the point. 1.03. What is the ratio of the % of value added in manufacturing in Bolivia in 1996 to that in 1998?
Ensure brevity in your answer.  0.89. What is the ratio of the % of value added in manufacturing in Botswana in 1996 to that in 1998?
Your answer should be compact. 1.1. What is the ratio of the % of value added in manufacturing of Italy in 1996 to that in 1998?
Your answer should be compact. 0.96. What is the ratio of the % of value added in manufacturing of Uganda in 1996 to that in 1998?
Keep it short and to the point. 0.77. What is the ratio of the % of value added in manufacturing in Bolivia in 1997 to that in 1998?
Your answer should be very brief. 0.96. What is the ratio of the % of value added in manufacturing of Botswana in 1997 to that in 1998?
Give a very brief answer. 1.6. What is the ratio of the % of value added in manufacturing of Italy in 1997 to that in 1998?
Provide a succinct answer. 0.93. What is the ratio of the % of value added in manufacturing in Uganda in 1997 to that in 1998?
Your response must be concise. 0.75. What is the difference between the highest and the second highest % of value added in manufacturing of Bolivia?
Provide a succinct answer. 0.94. What is the difference between the highest and the second highest % of value added in manufacturing in Botswana?
Give a very brief answer. 4.3. What is the difference between the highest and the second highest % of value added in manufacturing of Italy?
Offer a very short reply. 0.51. What is the difference between the highest and the second highest % of value added in manufacturing of Uganda?
Offer a very short reply. 14.8. What is the difference between the highest and the lowest % of value added in manufacturing of Bolivia?
Your answer should be compact. 4.64. What is the difference between the highest and the lowest % of value added in manufacturing of Botswana?
Ensure brevity in your answer.  26.79. What is the difference between the highest and the lowest % of value added in manufacturing in Italy?
Provide a short and direct response. 1.16. What is the difference between the highest and the lowest % of value added in manufacturing of Uganda?
Keep it short and to the point. 19.16. 